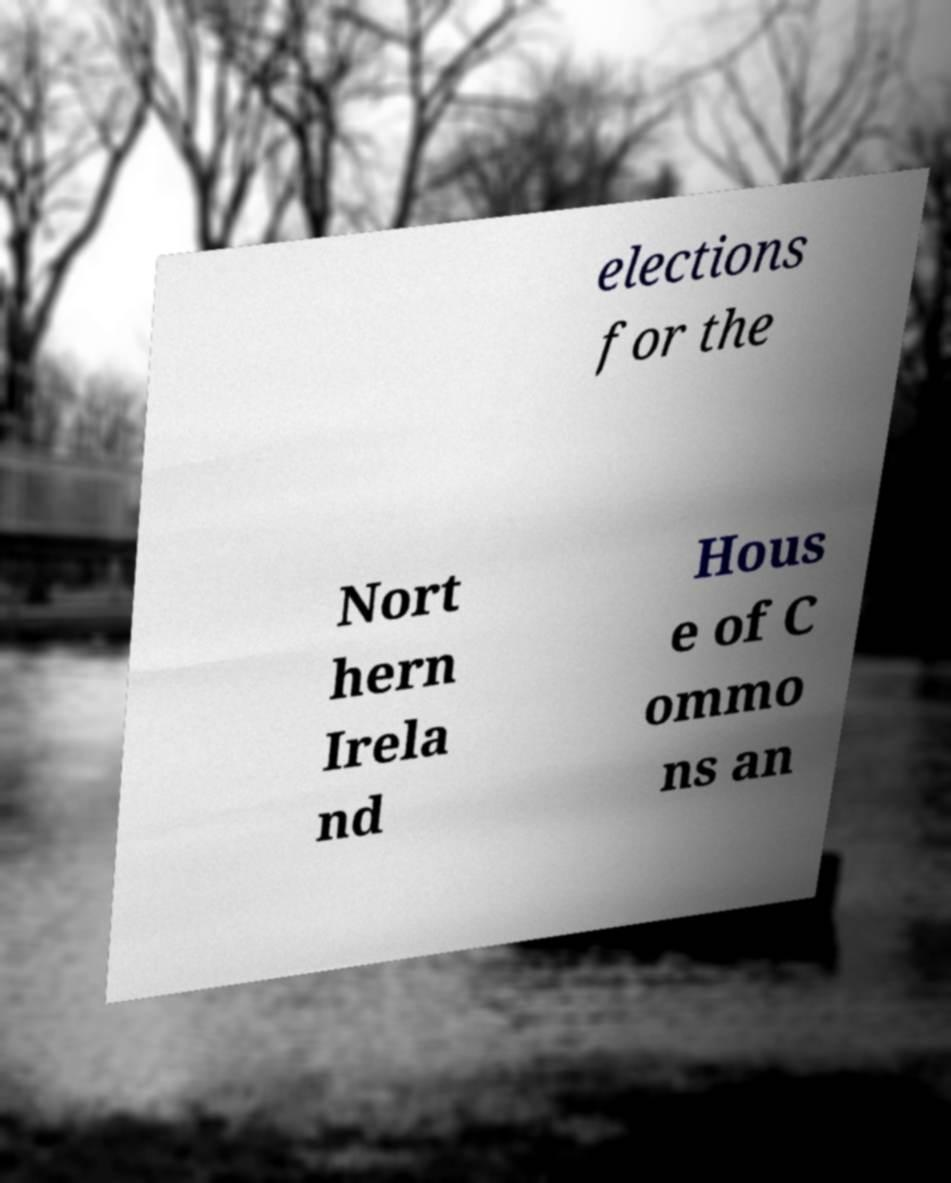I need the written content from this picture converted into text. Can you do that? elections for the Nort hern Irela nd Hous e of C ommo ns an 